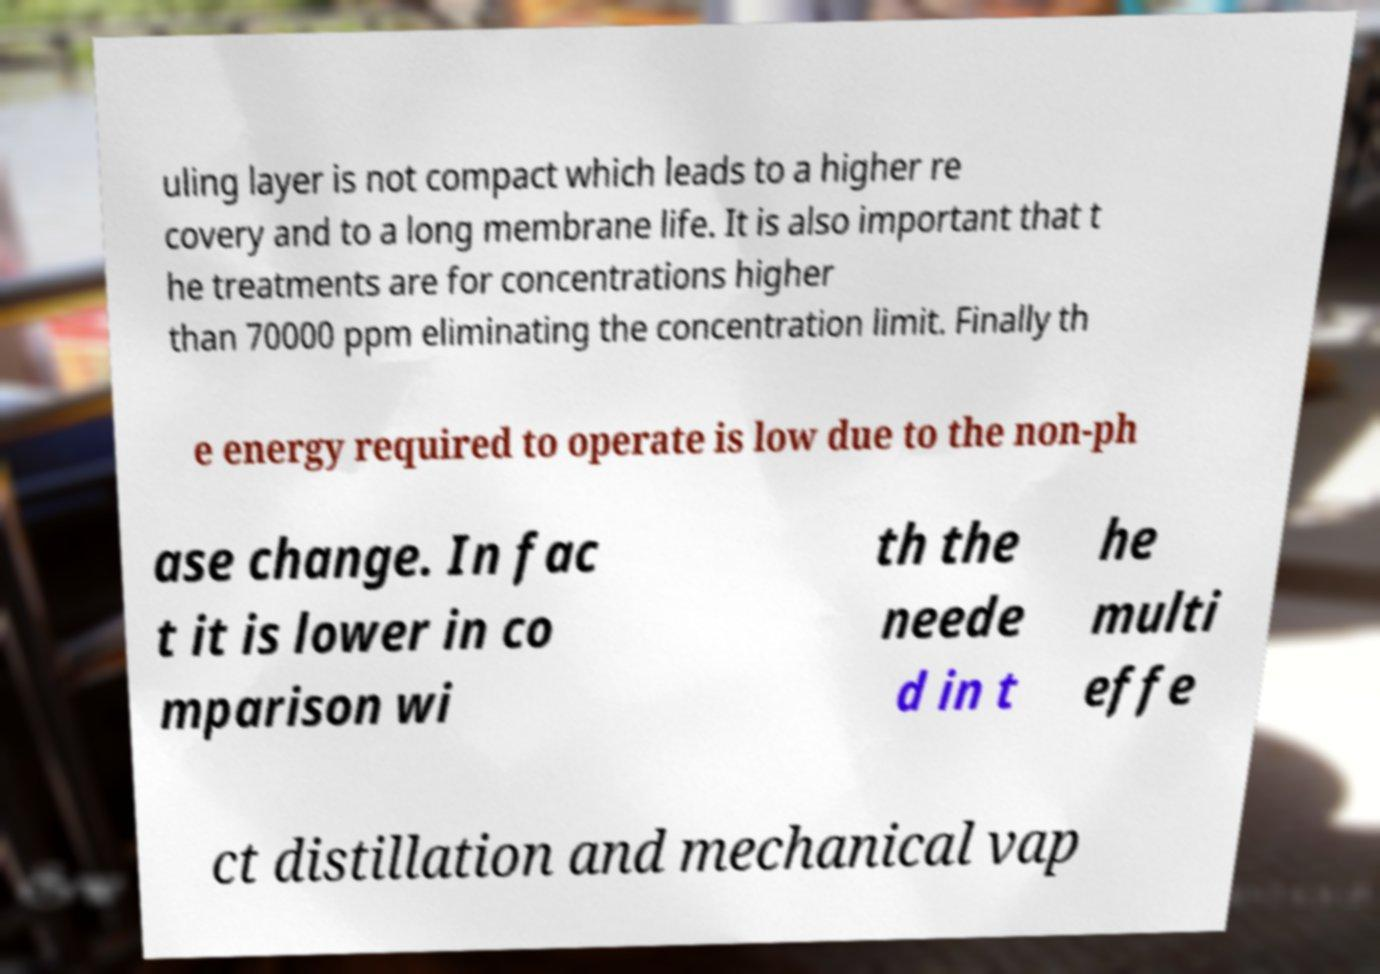Please identify and transcribe the text found in this image. uling layer is not compact which leads to a higher re covery and to a long membrane life. It is also important that t he treatments are for concentrations higher than 70000 ppm eliminating the concentration limit. Finally th e energy required to operate is low due to the non-ph ase change. In fac t it is lower in co mparison wi th the neede d in t he multi effe ct distillation and mechanical vap 